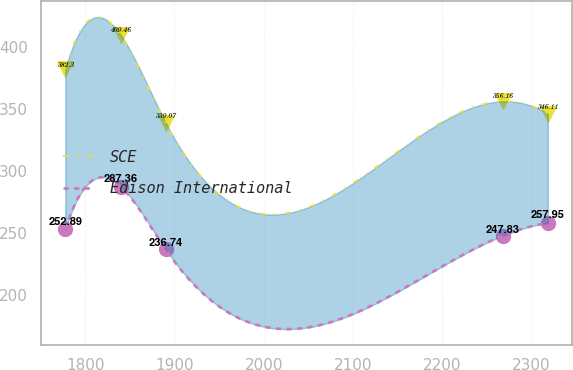Convert chart to OTSL. <chart><loc_0><loc_0><loc_500><loc_500><line_chart><ecel><fcel>SCE<fcel>Edison International<nl><fcel>1777.62<fcel>382.3<fcel>252.89<nl><fcel>1839.93<fcel>409.46<fcel>287.36<nl><fcel>1890.14<fcel>339.07<fcel>236.74<nl><fcel>2268.22<fcel>356.16<fcel>247.83<nl><fcel>2318.43<fcel>346.11<fcel>257.95<nl></chart> 